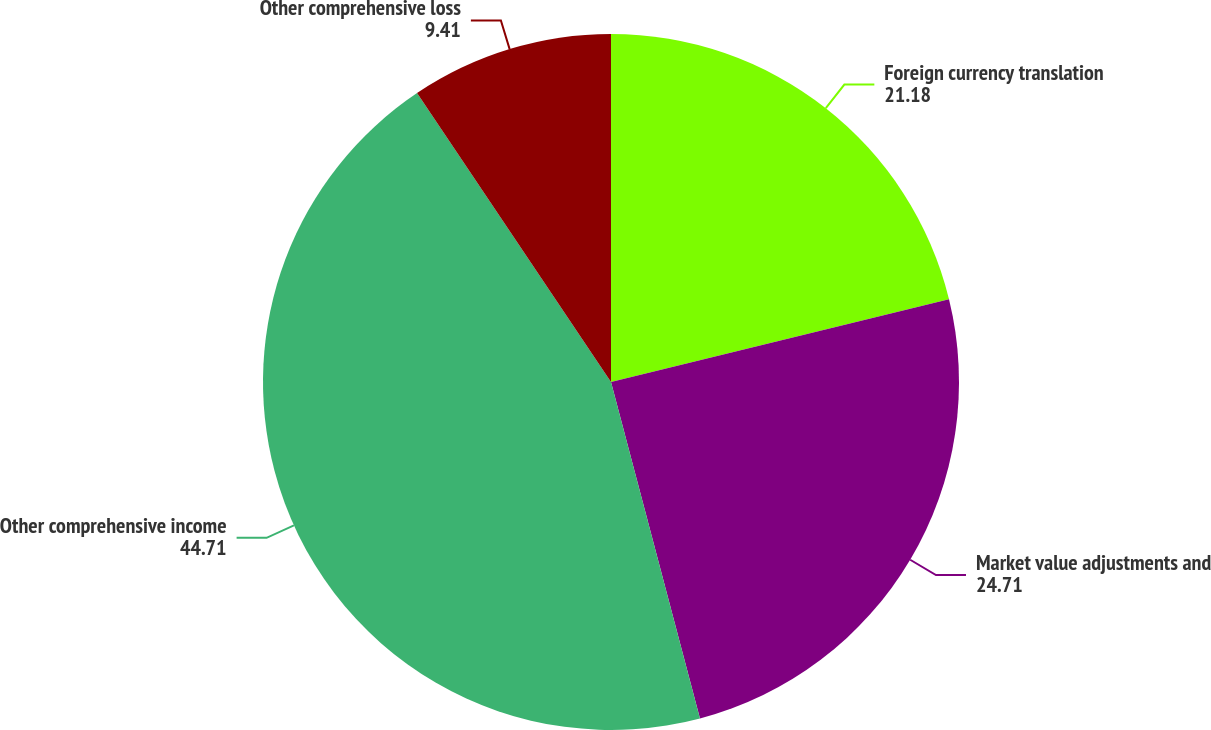<chart> <loc_0><loc_0><loc_500><loc_500><pie_chart><fcel>Foreign currency translation<fcel>Market value adjustments and<fcel>Other comprehensive income<fcel>Other comprehensive loss<nl><fcel>21.18%<fcel>24.71%<fcel>44.71%<fcel>9.41%<nl></chart> 